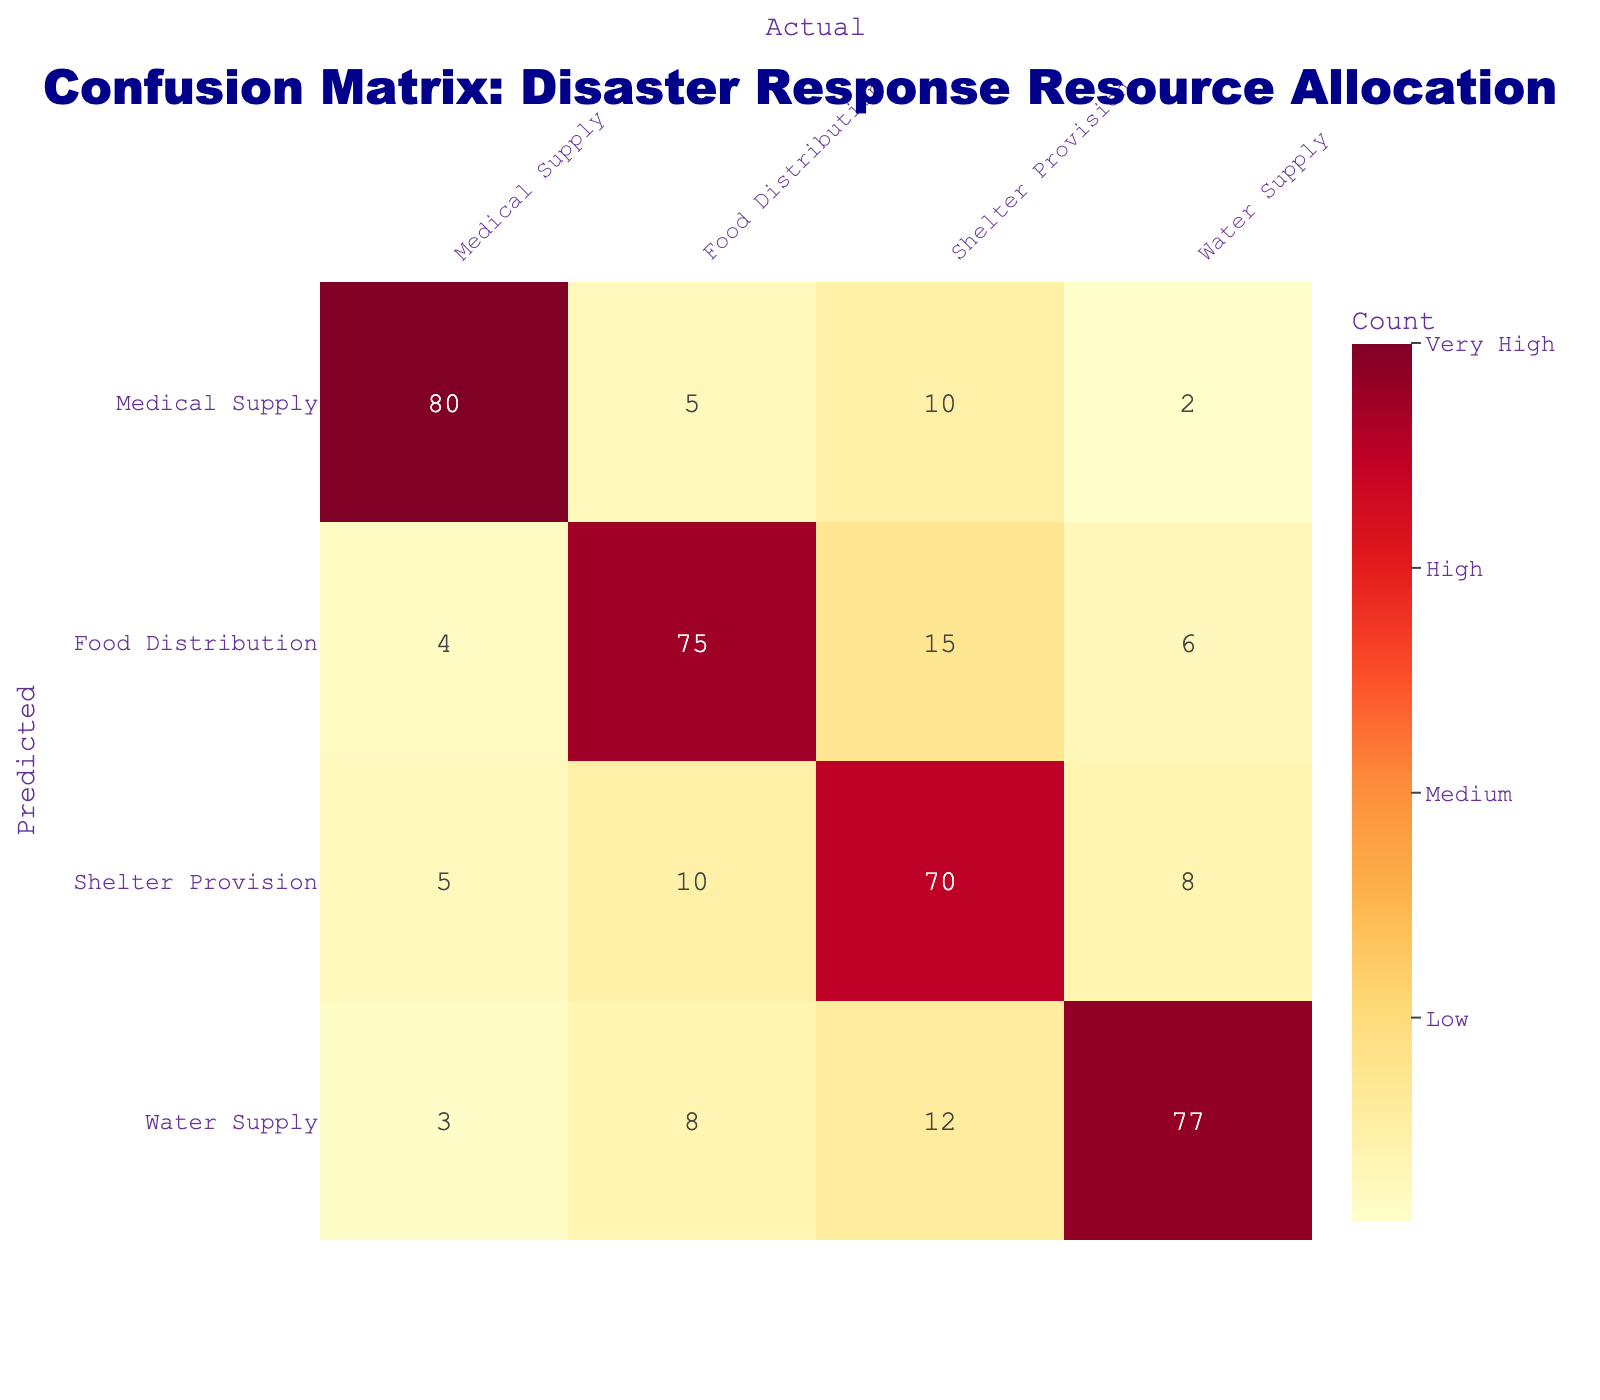What is the total number of predictions for Food Distribution? To find the total number of predictions for Food Distribution, I will sum all the values in the Food Distribution column: 4 (medical supply) + 75 (food distribution) + 15 (shelter provision) + 6 (water supply) = 100.
Answer: 100 What is the predicted value for Shelter Provision when the actual is Water Supply? Referring to the confusion matrix, the predicted value for Shelter Provision when the actual is Water Supply is found in the corresponding cell: it is 12.
Answer: 12 Is the number of correct predictions for Water Supply greater than for Food Distribution? The correct predictions for Water Supply are 77, while for Food Distribution they are 75. Since 77 is greater than 75, the statement is true.
Answer: Yes What is the average number of misallocated resources across all categories? To calculate the misallocated resources, I need to first find the total misallocations. This is done by summing the off-diagonal elements: 5 (medical supply) + 10 (medical supply) + 4 (food distribution) + 15 (food distribution) + 10 (shelter provision) + 8 (shelter provision) + 3 (water supply) + 8 (water supply) + 12 (water supply) = 81. Now, divide this total misallocation by the total number of categories (4): 81/4 = 20.25. The average misallocated resources are thus 20.25.
Answer: 20.25 What is the highest count of correct predictions and for which resource? Examining the diagonal elements of the confusion matrix, the highest count of correct predictions is 80 for Medical Supply.
Answer: 80 for Medical Supply 